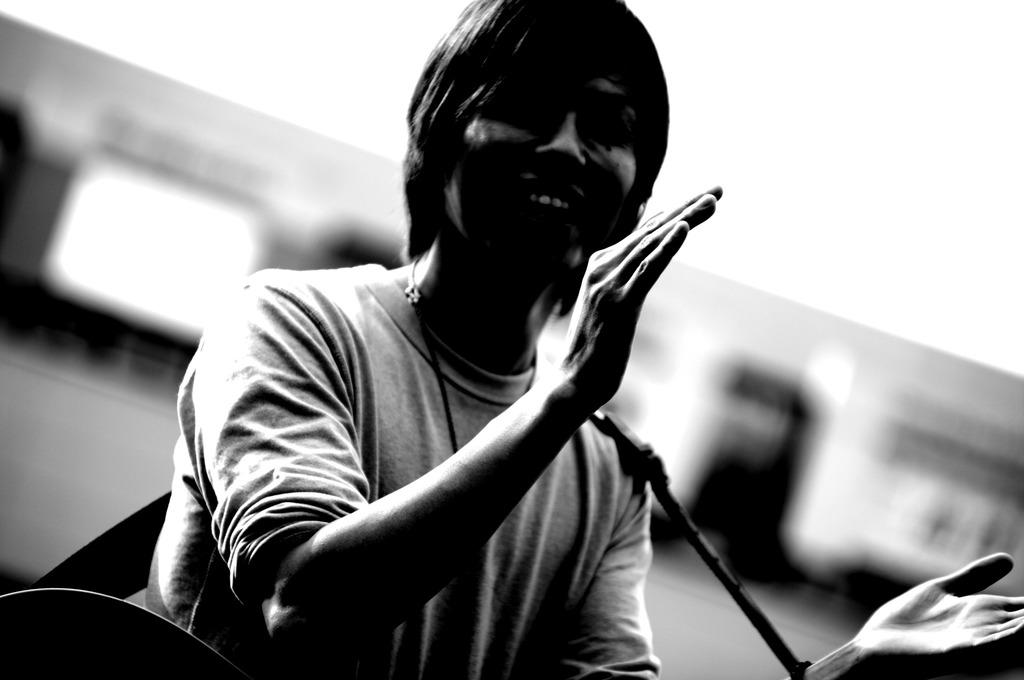What is the main subject of the image? There is a person in the image. What is the person wearing? The person is wearing a T-shirt. What is the person carrying? The person is carrying a guitar. What is the person's facial expression? The person is smiling. Can you describe the background of the image? The background of the image is blurred. What type of lock can be seen on the person's stocking in the image? There is no lock or stocking present in the image. How much salt is visible on the person's guitar in the image? There is no salt visible on the person's guitar in the image. 